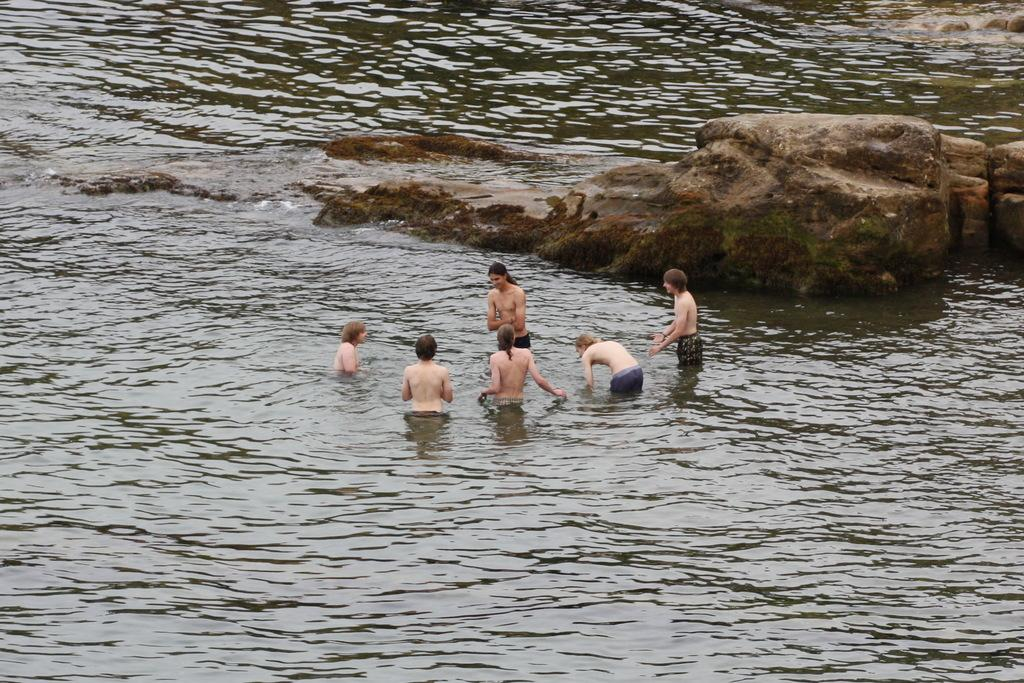What are the people in the image doing? The persons are standing in the water in the center of the image. What can be seen in the background of the image? There are rocks in the background of the image. What is the primary element visible in the image? Water is visible in the image. What type of kite can be seen flying in the image? There is no kite present in the image; it features persons standing in the water and rocks in the background. 